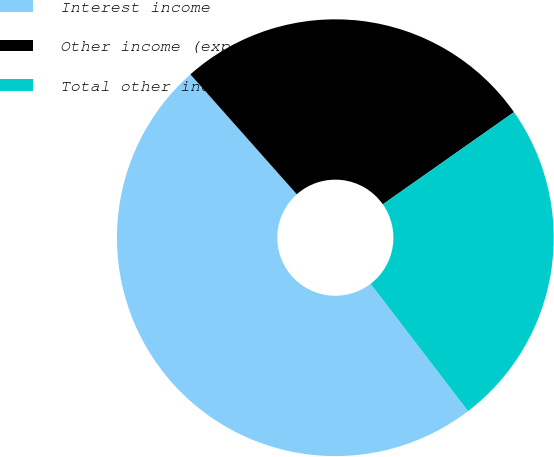<chart> <loc_0><loc_0><loc_500><loc_500><pie_chart><fcel>Interest income<fcel>Other income (expense) net<fcel>Total other income and expense<nl><fcel>48.85%<fcel>26.8%<fcel>24.35%<nl></chart> 